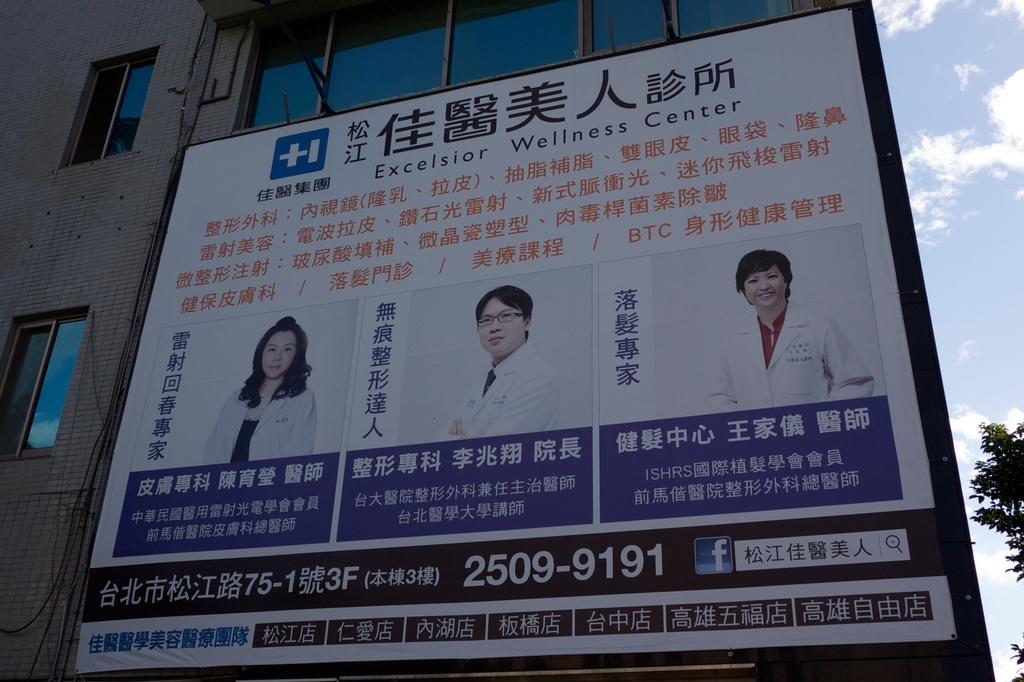What is this building used as?
Make the answer very short. Wellness center. 